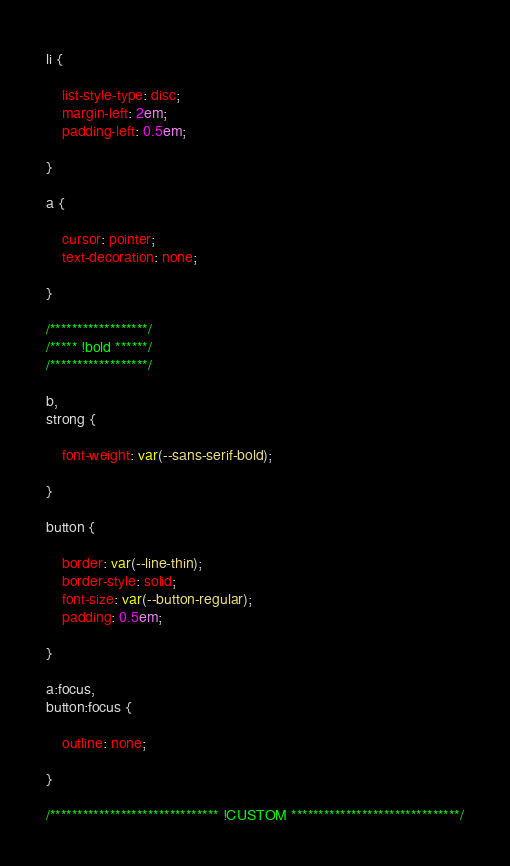<code> <loc_0><loc_0><loc_500><loc_500><_CSS_>
li {
    
    list-style-type: disc;
    margin-left: 2em;
    padding-left: 0.5em;
    
}

a {
	
	cursor: pointer;
    text-decoration: none;
	
}

/******************/
/***** !bold ******/
/******************/

b, 
strong {
    
    font-weight: var(--sans-serif-bold);
    
}

button {
	
	border: var(--line-thin);
	border-style: solid;
	font-size: var(--button-regular);
	padding: 0.5em;
	
}

a:focus,
button:focus {
	
	outline: none;
	
}

/******************************* !CUSTOM *******************************/</code> 